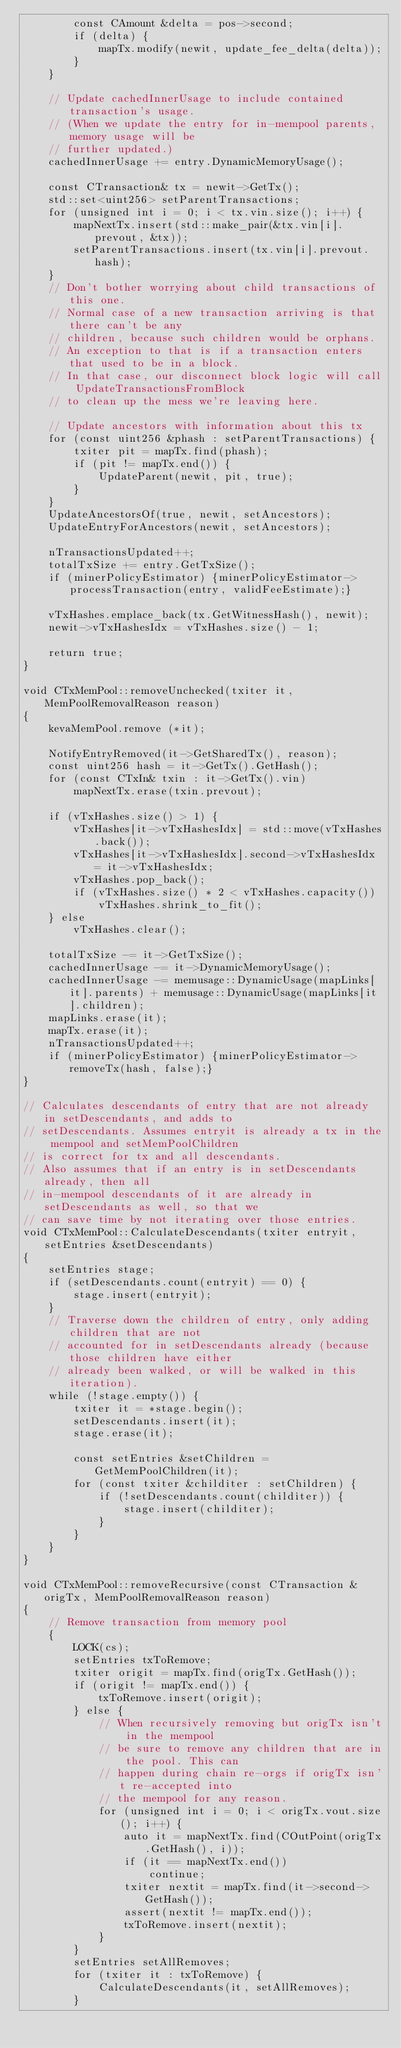Convert code to text. <code><loc_0><loc_0><loc_500><loc_500><_C++_>        const CAmount &delta = pos->second;
        if (delta) {
            mapTx.modify(newit, update_fee_delta(delta));
        }
    }

    // Update cachedInnerUsage to include contained transaction's usage.
    // (When we update the entry for in-mempool parents, memory usage will be
    // further updated.)
    cachedInnerUsage += entry.DynamicMemoryUsage();

    const CTransaction& tx = newit->GetTx();
    std::set<uint256> setParentTransactions;
    for (unsigned int i = 0; i < tx.vin.size(); i++) {
        mapNextTx.insert(std::make_pair(&tx.vin[i].prevout, &tx));
        setParentTransactions.insert(tx.vin[i].prevout.hash);
    }
    // Don't bother worrying about child transactions of this one.
    // Normal case of a new transaction arriving is that there can't be any
    // children, because such children would be orphans.
    // An exception to that is if a transaction enters that used to be in a block.
    // In that case, our disconnect block logic will call UpdateTransactionsFromBlock
    // to clean up the mess we're leaving here.

    // Update ancestors with information about this tx
    for (const uint256 &phash : setParentTransactions) {
        txiter pit = mapTx.find(phash);
        if (pit != mapTx.end()) {
            UpdateParent(newit, pit, true);
        }
    }
    UpdateAncestorsOf(true, newit, setAncestors);
    UpdateEntryForAncestors(newit, setAncestors);

    nTransactionsUpdated++;
    totalTxSize += entry.GetTxSize();
    if (minerPolicyEstimator) {minerPolicyEstimator->processTransaction(entry, validFeeEstimate);}

    vTxHashes.emplace_back(tx.GetWitnessHash(), newit);
    newit->vTxHashesIdx = vTxHashes.size() - 1;

    return true;
}

void CTxMemPool::removeUnchecked(txiter it, MemPoolRemovalReason reason)
{
    kevaMemPool.remove (*it);

    NotifyEntryRemoved(it->GetSharedTx(), reason);
    const uint256 hash = it->GetTx().GetHash();
    for (const CTxIn& txin : it->GetTx().vin)
        mapNextTx.erase(txin.prevout);

    if (vTxHashes.size() > 1) {
        vTxHashes[it->vTxHashesIdx] = std::move(vTxHashes.back());
        vTxHashes[it->vTxHashesIdx].second->vTxHashesIdx = it->vTxHashesIdx;
        vTxHashes.pop_back();
        if (vTxHashes.size() * 2 < vTxHashes.capacity())
            vTxHashes.shrink_to_fit();
    } else
        vTxHashes.clear();

    totalTxSize -= it->GetTxSize();
    cachedInnerUsage -= it->DynamicMemoryUsage();
    cachedInnerUsage -= memusage::DynamicUsage(mapLinks[it].parents) + memusage::DynamicUsage(mapLinks[it].children);
    mapLinks.erase(it);
    mapTx.erase(it);
    nTransactionsUpdated++;
    if (minerPolicyEstimator) {minerPolicyEstimator->removeTx(hash, false);}
}

// Calculates descendants of entry that are not already in setDescendants, and adds to
// setDescendants. Assumes entryit is already a tx in the mempool and setMemPoolChildren
// is correct for tx and all descendants.
// Also assumes that if an entry is in setDescendants already, then all
// in-mempool descendants of it are already in setDescendants as well, so that we
// can save time by not iterating over those entries.
void CTxMemPool::CalculateDescendants(txiter entryit, setEntries &setDescendants)
{
    setEntries stage;
    if (setDescendants.count(entryit) == 0) {
        stage.insert(entryit);
    }
    // Traverse down the children of entry, only adding children that are not
    // accounted for in setDescendants already (because those children have either
    // already been walked, or will be walked in this iteration).
    while (!stage.empty()) {
        txiter it = *stage.begin();
        setDescendants.insert(it);
        stage.erase(it);

        const setEntries &setChildren = GetMemPoolChildren(it);
        for (const txiter &childiter : setChildren) {
            if (!setDescendants.count(childiter)) {
                stage.insert(childiter);
            }
        }
    }
}

void CTxMemPool::removeRecursive(const CTransaction &origTx, MemPoolRemovalReason reason)
{
    // Remove transaction from memory pool
    {
        LOCK(cs);
        setEntries txToRemove;
        txiter origit = mapTx.find(origTx.GetHash());
        if (origit != mapTx.end()) {
            txToRemove.insert(origit);
        } else {
            // When recursively removing but origTx isn't in the mempool
            // be sure to remove any children that are in the pool. This can
            // happen during chain re-orgs if origTx isn't re-accepted into
            // the mempool for any reason.
            for (unsigned int i = 0; i < origTx.vout.size(); i++) {
                auto it = mapNextTx.find(COutPoint(origTx.GetHash(), i));
                if (it == mapNextTx.end())
                    continue;
                txiter nextit = mapTx.find(it->second->GetHash());
                assert(nextit != mapTx.end());
                txToRemove.insert(nextit);
            }
        }
        setEntries setAllRemoves;
        for (txiter it : txToRemove) {
            CalculateDescendants(it, setAllRemoves);
        }
</code> 